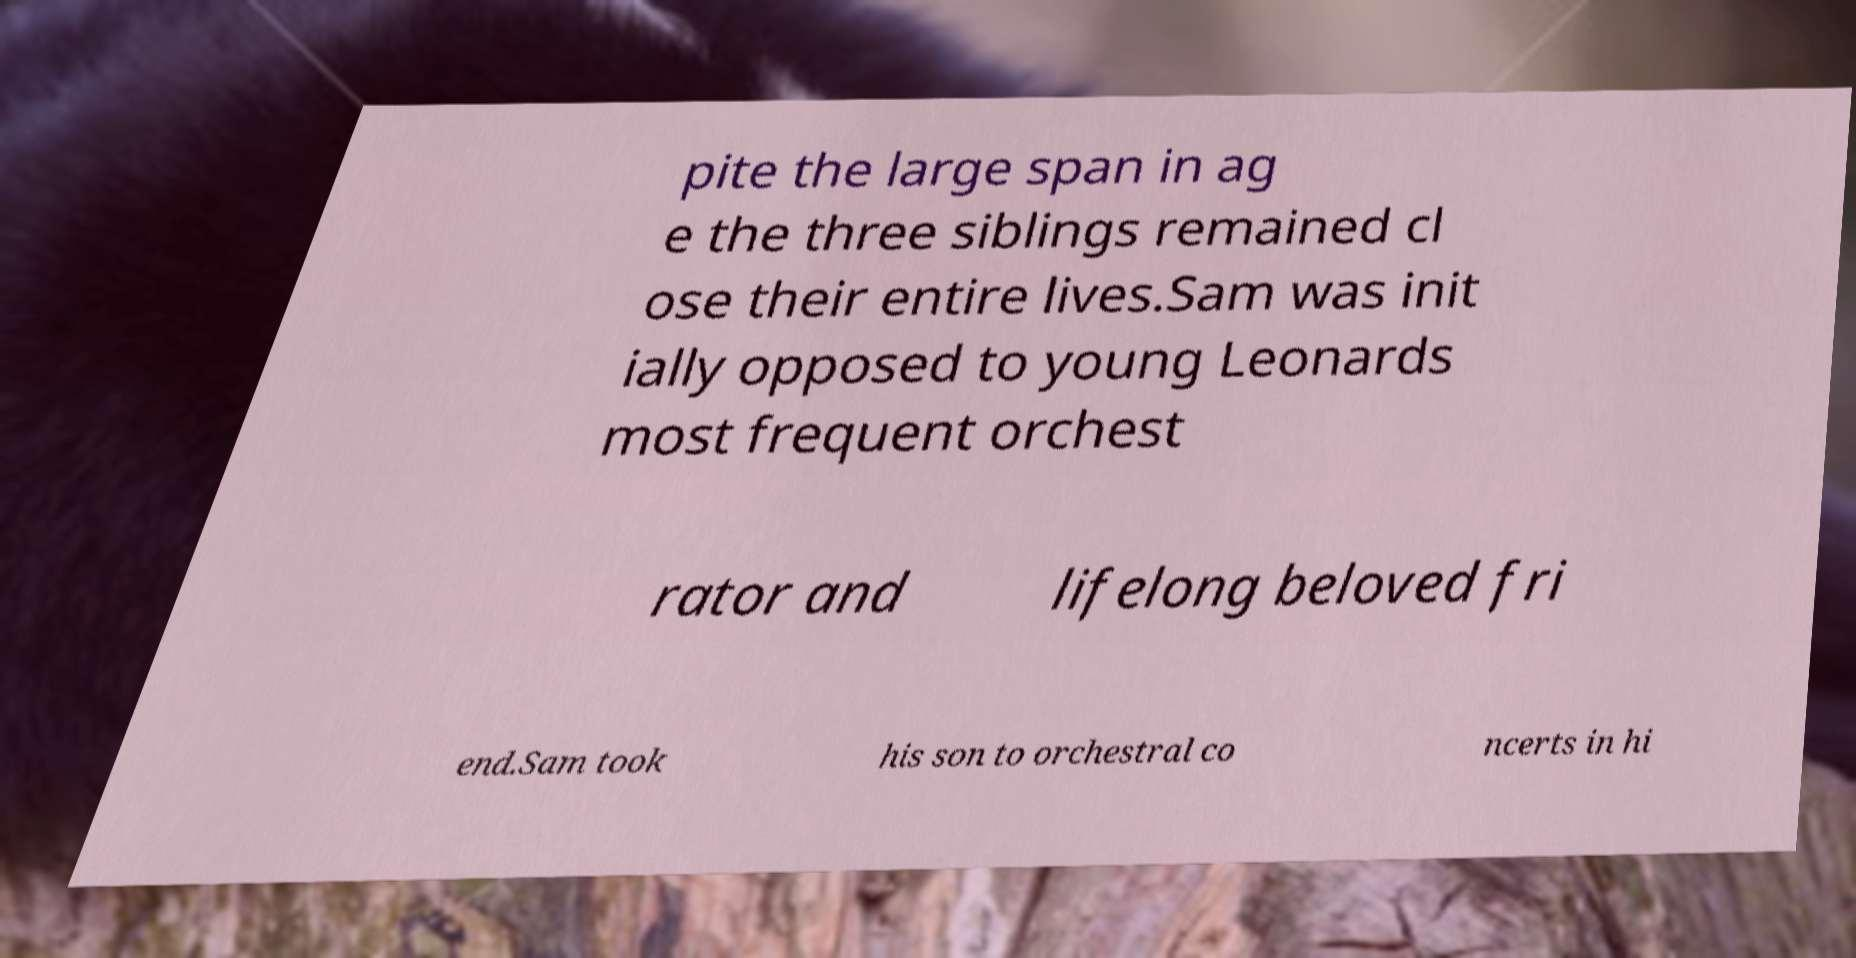There's text embedded in this image that I need extracted. Can you transcribe it verbatim? pite the large span in ag e the three siblings remained cl ose their entire lives.Sam was init ially opposed to young Leonards most frequent orchest rator and lifelong beloved fri end.Sam took his son to orchestral co ncerts in hi 